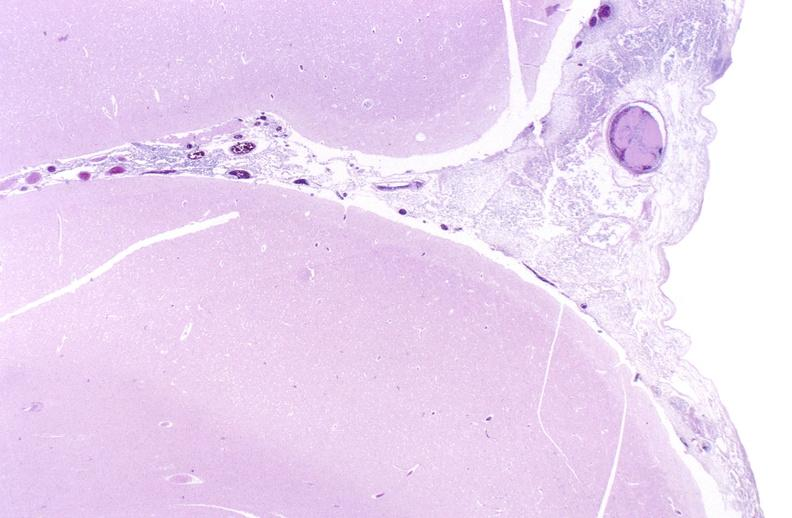where is this?
Answer the question using a single word or phrase. Nervous 